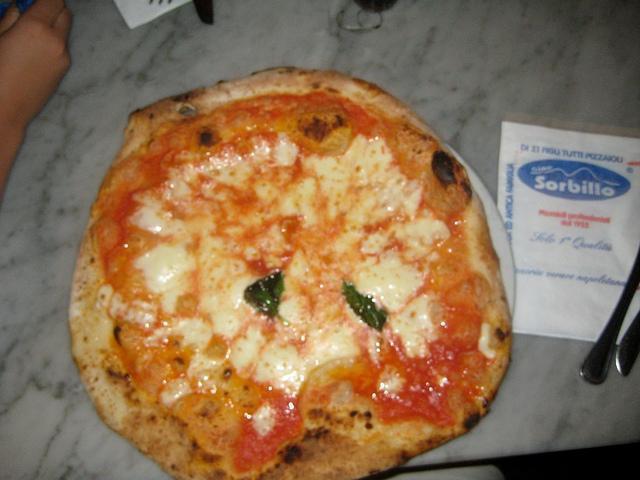Is this affirmation: "The person is at the left side of the pizza." correct?
Answer yes or no. Yes. 